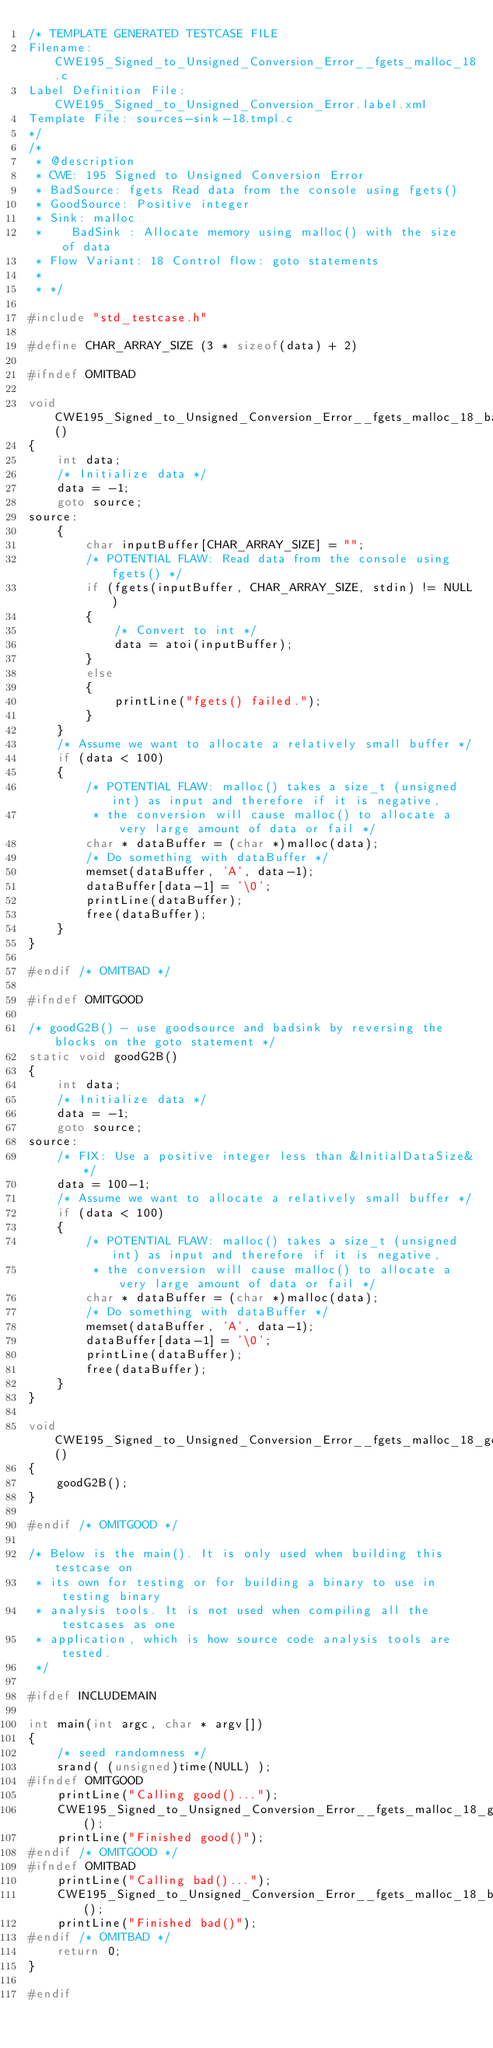<code> <loc_0><loc_0><loc_500><loc_500><_C_>/* TEMPLATE GENERATED TESTCASE FILE
Filename: CWE195_Signed_to_Unsigned_Conversion_Error__fgets_malloc_18.c
Label Definition File: CWE195_Signed_to_Unsigned_Conversion_Error.label.xml
Template File: sources-sink-18.tmpl.c
*/
/*
 * @description
 * CWE: 195 Signed to Unsigned Conversion Error
 * BadSource: fgets Read data from the console using fgets()
 * GoodSource: Positive integer
 * Sink: malloc
 *    BadSink : Allocate memory using malloc() with the size of data
 * Flow Variant: 18 Control flow: goto statements
 *
 * */

#include "std_testcase.h"

#define CHAR_ARRAY_SIZE (3 * sizeof(data) + 2)

#ifndef OMITBAD

void CWE195_Signed_to_Unsigned_Conversion_Error__fgets_malloc_18_bad()
{
    int data;
    /* Initialize data */
    data = -1;
    goto source;
source:
    {
        char inputBuffer[CHAR_ARRAY_SIZE] = "";
        /* POTENTIAL FLAW: Read data from the console using fgets() */
        if (fgets(inputBuffer, CHAR_ARRAY_SIZE, stdin) != NULL)
        {
            /* Convert to int */
            data = atoi(inputBuffer);
        }
        else
        {
            printLine("fgets() failed.");
        }
    }
    /* Assume we want to allocate a relatively small buffer */
    if (data < 100)
    {
        /* POTENTIAL FLAW: malloc() takes a size_t (unsigned int) as input and therefore if it is negative,
         * the conversion will cause malloc() to allocate a very large amount of data or fail */
        char * dataBuffer = (char *)malloc(data);
        /* Do something with dataBuffer */
        memset(dataBuffer, 'A', data-1);
        dataBuffer[data-1] = '\0';
        printLine(dataBuffer);
        free(dataBuffer);
    }
}

#endif /* OMITBAD */

#ifndef OMITGOOD

/* goodG2B() - use goodsource and badsink by reversing the blocks on the goto statement */
static void goodG2B()
{
    int data;
    /* Initialize data */
    data = -1;
    goto source;
source:
    /* FIX: Use a positive integer less than &InitialDataSize&*/
    data = 100-1;
    /* Assume we want to allocate a relatively small buffer */
    if (data < 100)
    {
        /* POTENTIAL FLAW: malloc() takes a size_t (unsigned int) as input and therefore if it is negative,
         * the conversion will cause malloc() to allocate a very large amount of data or fail */
        char * dataBuffer = (char *)malloc(data);
        /* Do something with dataBuffer */
        memset(dataBuffer, 'A', data-1);
        dataBuffer[data-1] = '\0';
        printLine(dataBuffer);
        free(dataBuffer);
    }
}

void CWE195_Signed_to_Unsigned_Conversion_Error__fgets_malloc_18_good()
{
    goodG2B();
}

#endif /* OMITGOOD */

/* Below is the main(). It is only used when building this testcase on
 * its own for testing or for building a binary to use in testing binary
 * analysis tools. It is not used when compiling all the testcases as one
 * application, which is how source code analysis tools are tested.
 */

#ifdef INCLUDEMAIN

int main(int argc, char * argv[])
{
    /* seed randomness */
    srand( (unsigned)time(NULL) );
#ifndef OMITGOOD
    printLine("Calling good()...");
    CWE195_Signed_to_Unsigned_Conversion_Error__fgets_malloc_18_good();
    printLine("Finished good()");
#endif /* OMITGOOD */
#ifndef OMITBAD
    printLine("Calling bad()...");
    CWE195_Signed_to_Unsigned_Conversion_Error__fgets_malloc_18_bad();
    printLine("Finished bad()");
#endif /* OMITBAD */
    return 0;
}

#endif
</code> 